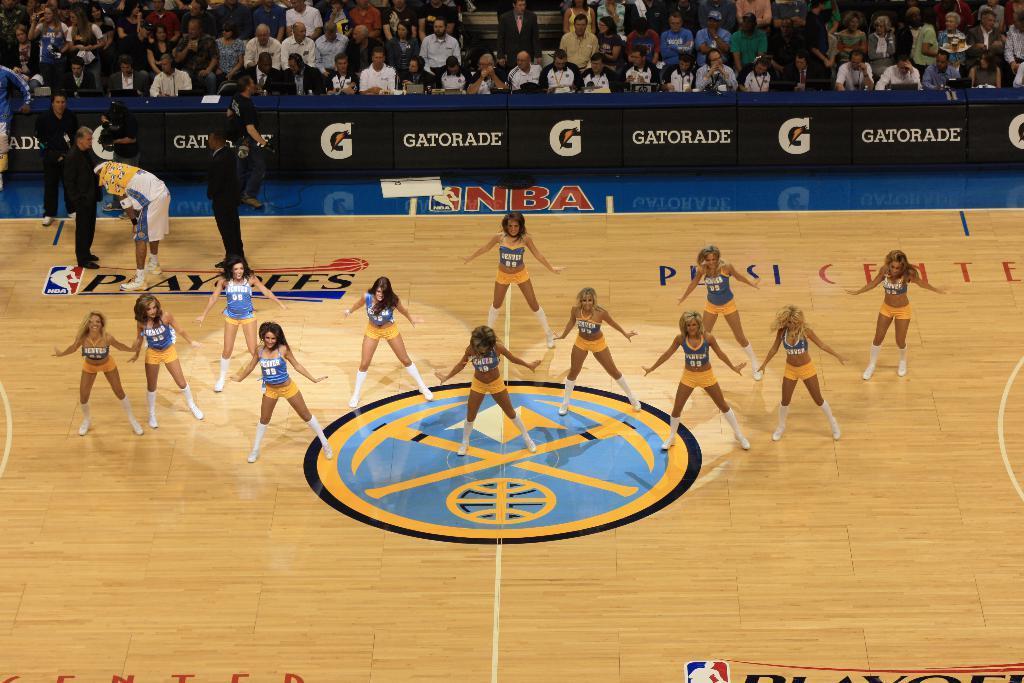Could you give a brief overview of what you see in this image? In the image we can see there are people standing and they are wearing the same costume. Here we can see wooden floor, poster and text on the poster. Here we can even see the audience. 